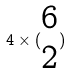<formula> <loc_0><loc_0><loc_500><loc_500>4 \times ( \begin{matrix} 6 \\ 2 \end{matrix} )</formula> 